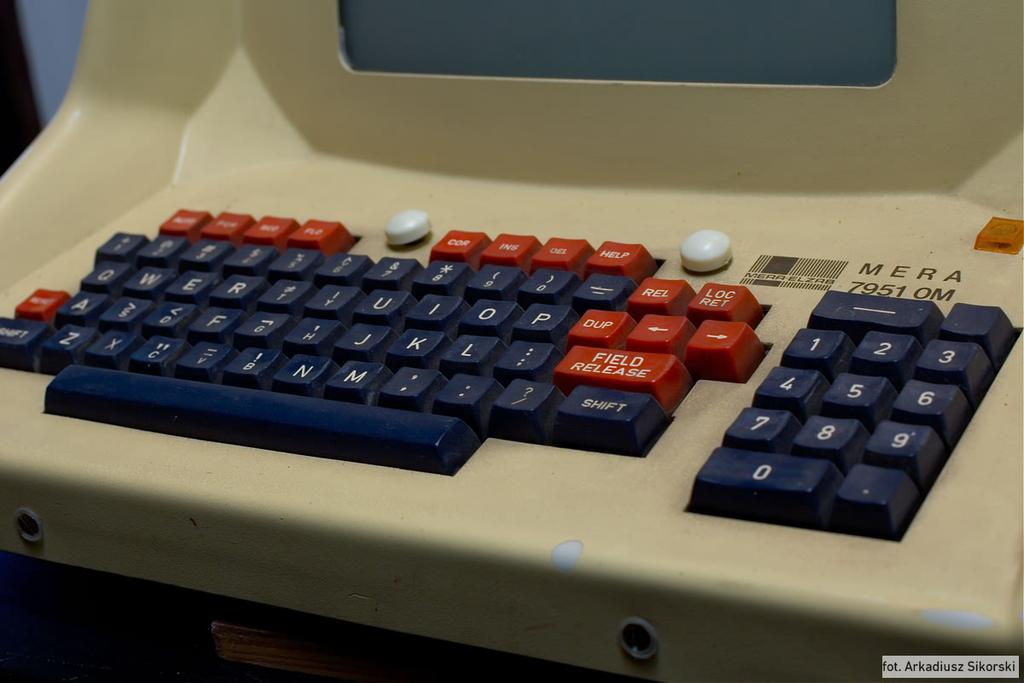<image>
Present a compact description of the photo's key features. A vintage MERA computer is showing the old blue and red keyboard. 